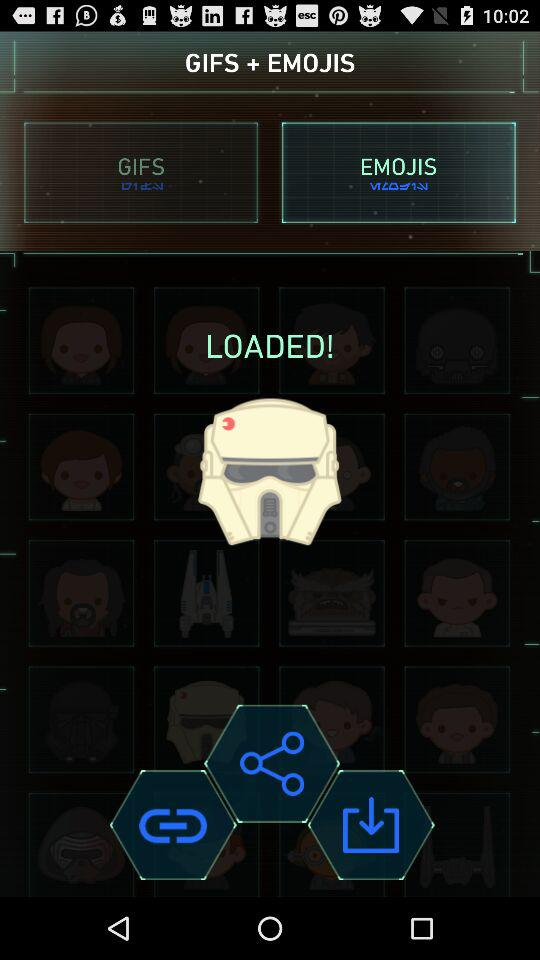Which tab is selected? The selected tab is "EMOJIS". 